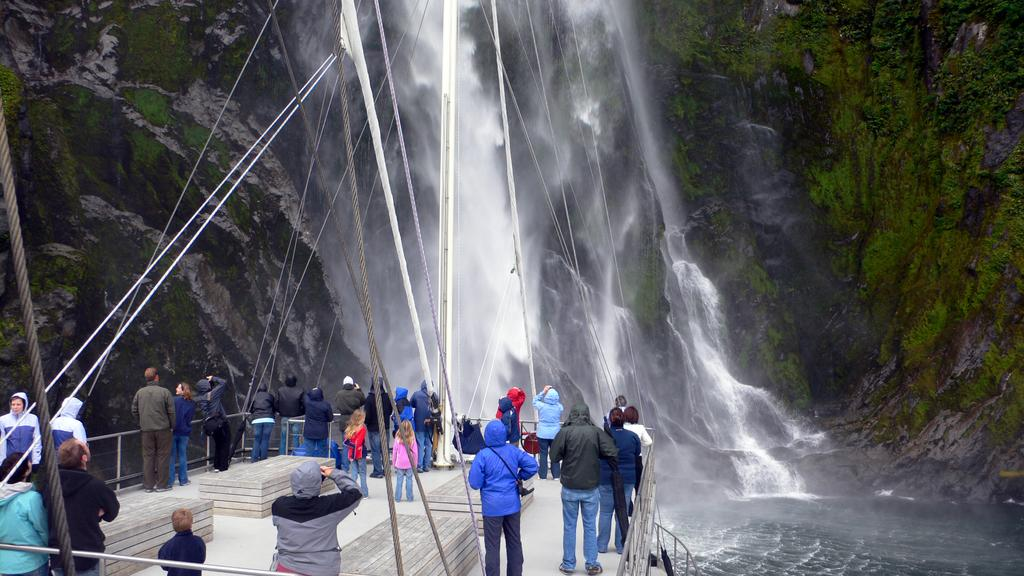What are the people in the image doing? The people in the image are standing on a boat. What is the primary setting of the image? Water is visible in the image. How is the water in the image behaving? The water appears to be flowing. What type of waste can be seen floating in the water in the image? There is no waste visible in the water in the image. What kind of bait is being used by the people on the boat in the image? There is no indication of fishing or bait in the image. 